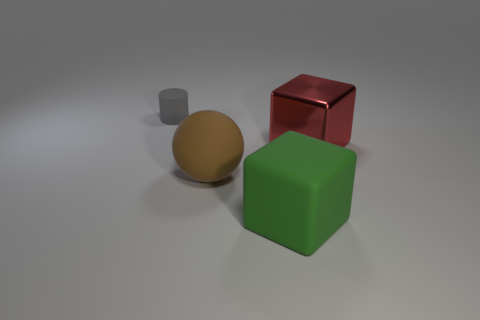What shape is the green thing that is the same material as the tiny cylinder?
Offer a terse response. Cube. Are the object in front of the big brown matte ball and the large brown thing made of the same material?
Keep it short and to the point. Yes. What number of objects are both behind the green cube and on the left side of the big metallic block?
Make the answer very short. 2. What material is the gray thing?
Your answer should be compact. Rubber. There is a brown rubber thing that is the same size as the matte cube; what is its shape?
Make the answer very short. Sphere. Is the material of the object that is behind the shiny cube the same as the red thing behind the large matte sphere?
Make the answer very short. No. What number of gray rubber cylinders are there?
Offer a very short reply. 1. What number of other rubber things have the same shape as the green matte thing?
Your answer should be compact. 0. Does the red metallic thing have the same shape as the tiny rubber object?
Your answer should be very brief. No. What is the size of the green matte thing?
Provide a short and direct response. Large. 